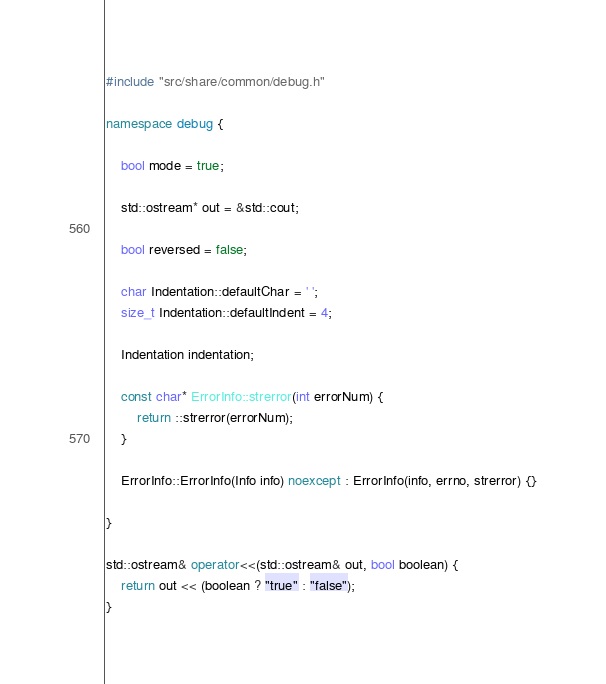Convert code to text. <code><loc_0><loc_0><loc_500><loc_500><_C++_>#include "src/share/common/debug.h"

namespace debug {
    
    bool mode = true;
    
    std::ostream* out = &std::cout;
    
    bool reversed = false;
    
    char Indentation::defaultChar = ' ';
    size_t Indentation::defaultIndent = 4;
    
    Indentation indentation;
    
    const char* ErrorInfo::strerror(int errorNum) {
        return ::strerror(errorNum);
    }
    
    ErrorInfo::ErrorInfo(Info info) noexcept : ErrorInfo(info, errno, strerror) {}
    
}

std::ostream& operator<<(std::ostream& out, bool boolean) {
    return out << (boolean ? "true" : "false");
}
</code> 